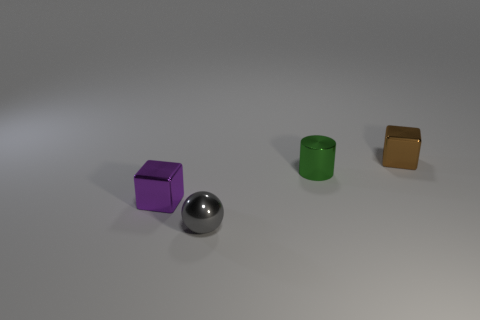There is another shiny thing that is the same shape as the purple object; what is its size?
Your response must be concise. Small. There is another tiny metallic thing that is the same shape as the tiny purple metal object; what is its color?
Your answer should be compact. Brown. There is a tiny ball; is its color the same as the small shiny object that is behind the green cylinder?
Offer a very short reply. No. There is another cube that is the same size as the brown metal block; what is its color?
Make the answer very short. Purple. Are there any big metal objects that have the same shape as the tiny green shiny object?
Your response must be concise. No. Is the number of green cylinders less than the number of big yellow matte cubes?
Your response must be concise. No. There is a tiny cube that is behind the green metallic thing; what is its color?
Provide a short and direct response. Brown. There is a tiny gray thing that is left of the small cube behind the tiny green metal cylinder; what is its shape?
Provide a succinct answer. Sphere. Is the material of the tiny sphere the same as the block on the right side of the tiny sphere?
Provide a short and direct response. Yes. How many brown metal blocks are the same size as the purple thing?
Offer a terse response. 1. 